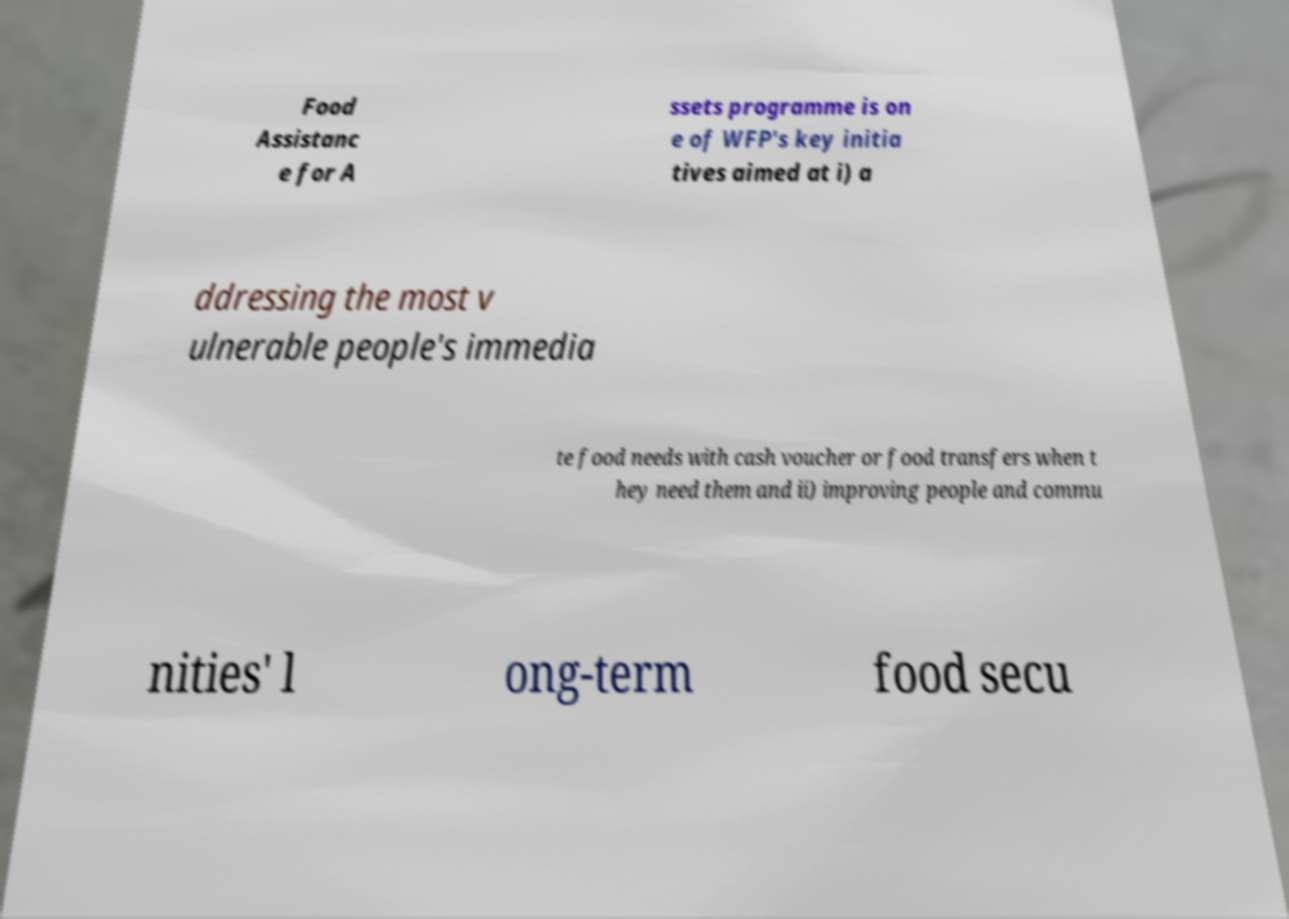Could you assist in decoding the text presented in this image and type it out clearly? Food Assistanc e for A ssets programme is on e of WFP's key initia tives aimed at i) a ddressing the most v ulnerable people's immedia te food needs with cash voucher or food transfers when t hey need them and ii) improving people and commu nities' l ong-term food secu 